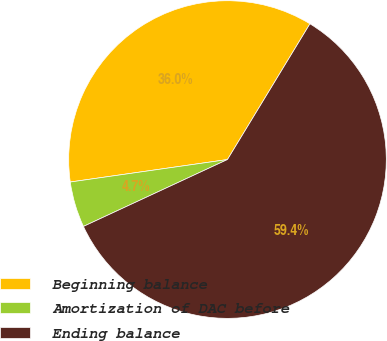<chart> <loc_0><loc_0><loc_500><loc_500><pie_chart><fcel>Beginning balance<fcel>Amortization of DAC before<fcel>Ending balance<nl><fcel>35.95%<fcel>4.66%<fcel>59.39%<nl></chart> 